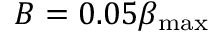Convert formula to latex. <formula><loc_0><loc_0><loc_500><loc_500>B = 0 . 0 5 \beta _ { \max }</formula> 